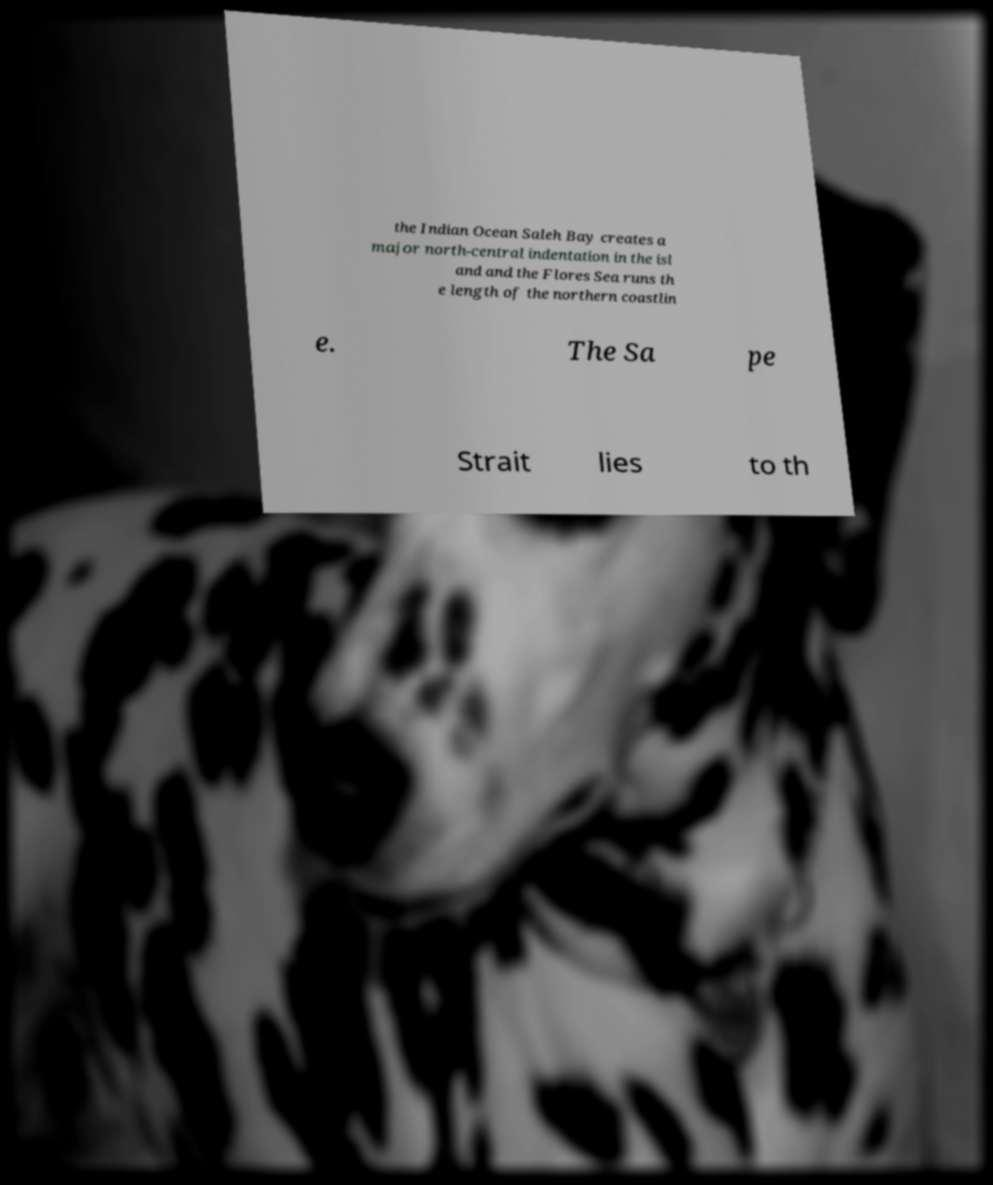For documentation purposes, I need the text within this image transcribed. Could you provide that? the Indian Ocean Saleh Bay creates a major north-central indentation in the isl and and the Flores Sea runs th e length of the northern coastlin e. The Sa pe Strait lies to th 